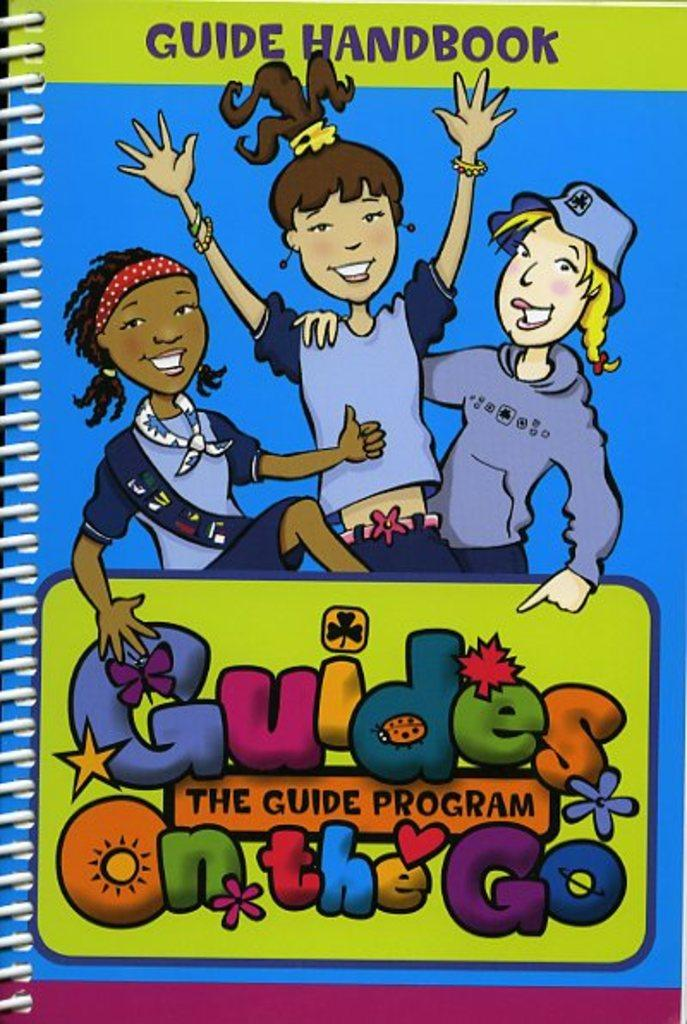What is the main subject of the image? The cover page of a book is visible in the image. Can you describe the colors used on the cover page? The cover page is blue and green in color. What can be seen on the cover page? There are three children smiling on the cover page. Are there any words on the cover page? Yes, there are words written on the cover page. What is the weight of the wine bottle in the image? There is no wine bottle present in the image; it features the cover page of a book with three smiling children. 